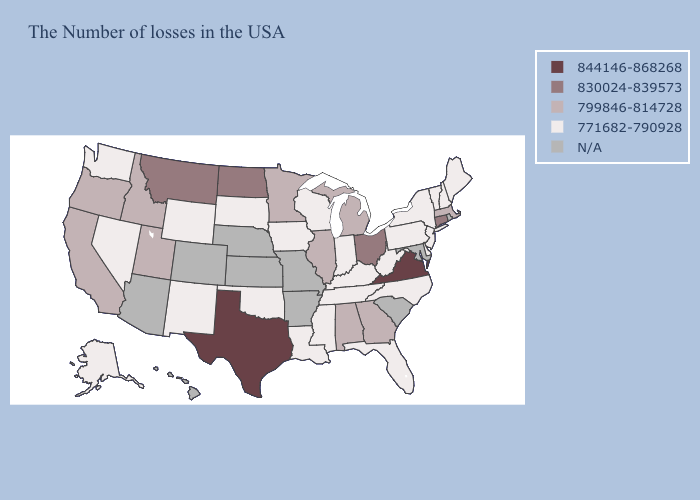Which states have the lowest value in the Northeast?
Write a very short answer. Maine, New Hampshire, Vermont, New York, New Jersey, Pennsylvania. Name the states that have a value in the range N/A?
Short answer required. Rhode Island, Maryland, South Carolina, Missouri, Arkansas, Kansas, Nebraska, Colorado, Arizona, Hawaii. Does Michigan have the lowest value in the MidWest?
Give a very brief answer. No. What is the value of Arizona?
Quick response, please. N/A. What is the value of New Jersey?
Be succinct. 771682-790928. Name the states that have a value in the range N/A?
Concise answer only. Rhode Island, Maryland, South Carolina, Missouri, Arkansas, Kansas, Nebraska, Colorado, Arizona, Hawaii. What is the value of Florida?
Give a very brief answer. 771682-790928. What is the lowest value in states that border Indiana?
Short answer required. 771682-790928. Among the states that border Idaho , which have the highest value?
Be succinct. Montana. Among the states that border South Carolina , which have the lowest value?
Give a very brief answer. North Carolina. Does Massachusetts have the lowest value in the USA?
Keep it brief. No. What is the value of Maryland?
Concise answer only. N/A. How many symbols are there in the legend?
Write a very short answer. 5. Does New Jersey have the highest value in the Northeast?
Concise answer only. No. 